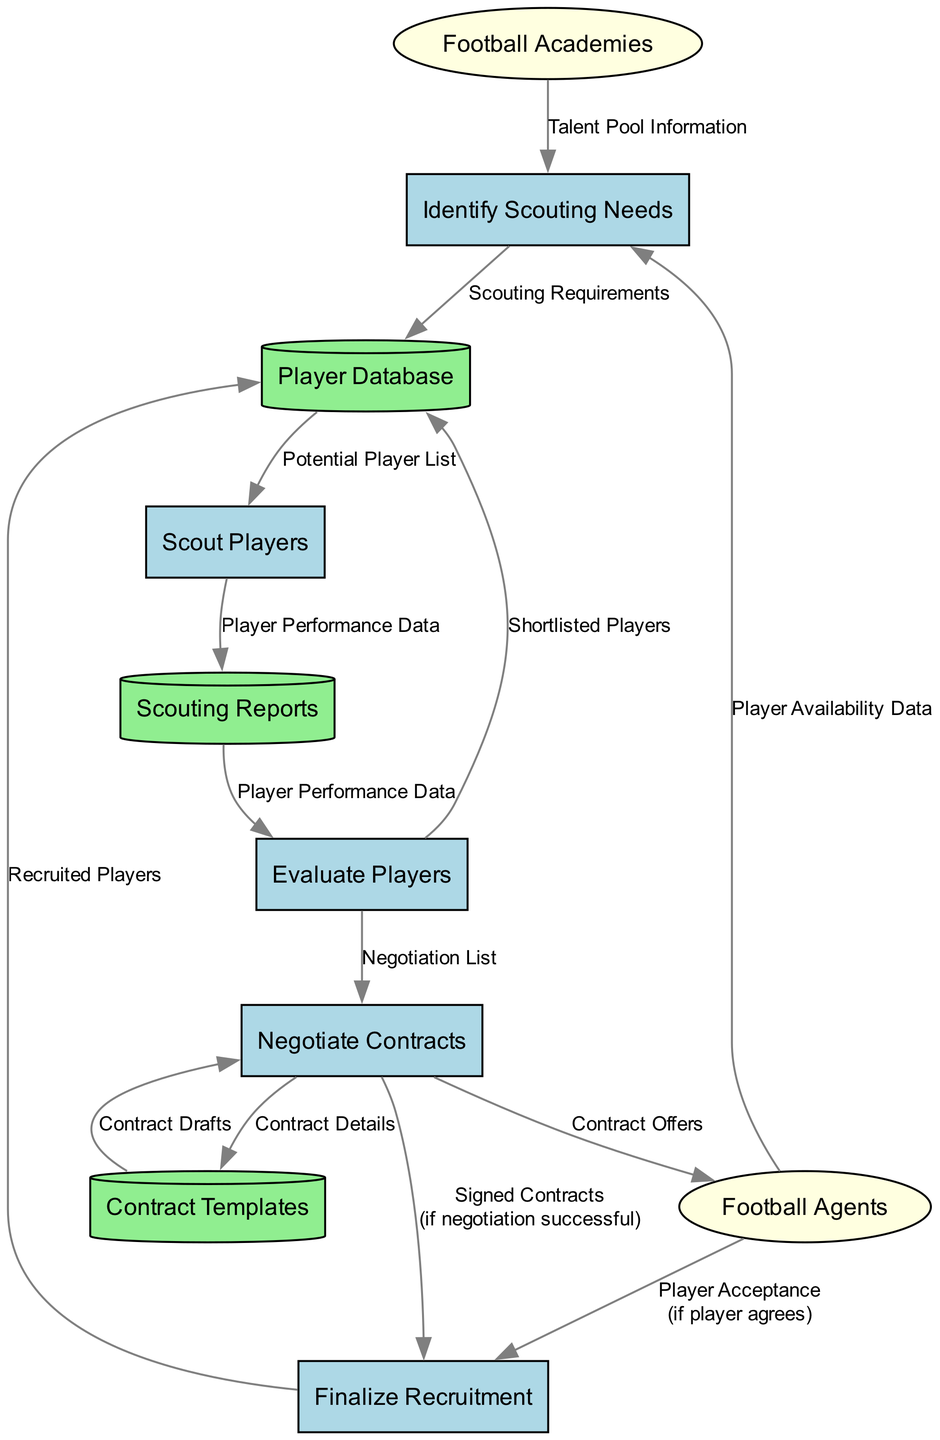What is the first process in the diagram? The first process listed in the diagram is "Identify Scouting Needs", which is labeled as process "1".
Answer: Identify Scouting Needs How many processes are there in total? By counting the processes listed in the diagram, there are five distinct processes.
Answer: 5 What data flows from Football Agents to Identify Scouting Needs? The data flowing from Football Agents to Identify Scouting Needs is labeled as "Player Availability Data".
Answer: Player Availability Data Which data store receives "Shortlisted Players"? The "Player Database" receives data labeled "Shortlisted Players" from the "Evaluate Players" process.
Answer: Player Database What is the condition for moving data from Negotiate Contracts to Finalize Recruitment? The condition mentioned for this data flow is "if negotiation successful", indicating a successful negotiation is required to proceed.
Answer: if negotiation successful What data is sent from Evaluate Players to Negotiate Contracts? The data sent from Evaluate Players to Negotiate Contracts is labeled as "Negotiation List".
Answer: Negotiation List Which external entity provides "Talent Pool Information"? The external entity that provides "Talent Pool Information" is "Football Academies".
Answer: Football Academies What type of data is contained in "Scouting Reports"? "Scouting Reports" contain "Player Performance Data" that has been gathered from scouting players.
Answer: Player Performance Data How many data stores are mentioned in the diagram? The diagram mentions three distinct data stores, which are "Player Database", "Scouting Reports", and "Contract Templates".
Answer: 3 